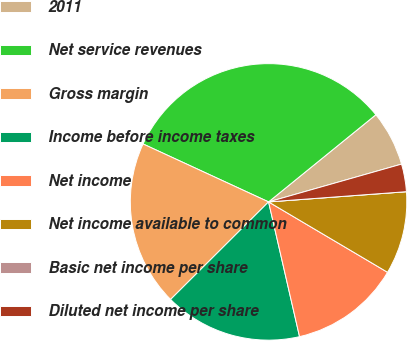Convert chart. <chart><loc_0><loc_0><loc_500><loc_500><pie_chart><fcel>2011<fcel>Net service revenues<fcel>Gross margin<fcel>Income before income taxes<fcel>Net income<fcel>Net income available to common<fcel>Basic net income per share<fcel>Diluted net income per share<nl><fcel>6.45%<fcel>32.26%<fcel>19.35%<fcel>16.13%<fcel>12.9%<fcel>9.68%<fcel>0.0%<fcel>3.23%<nl></chart> 